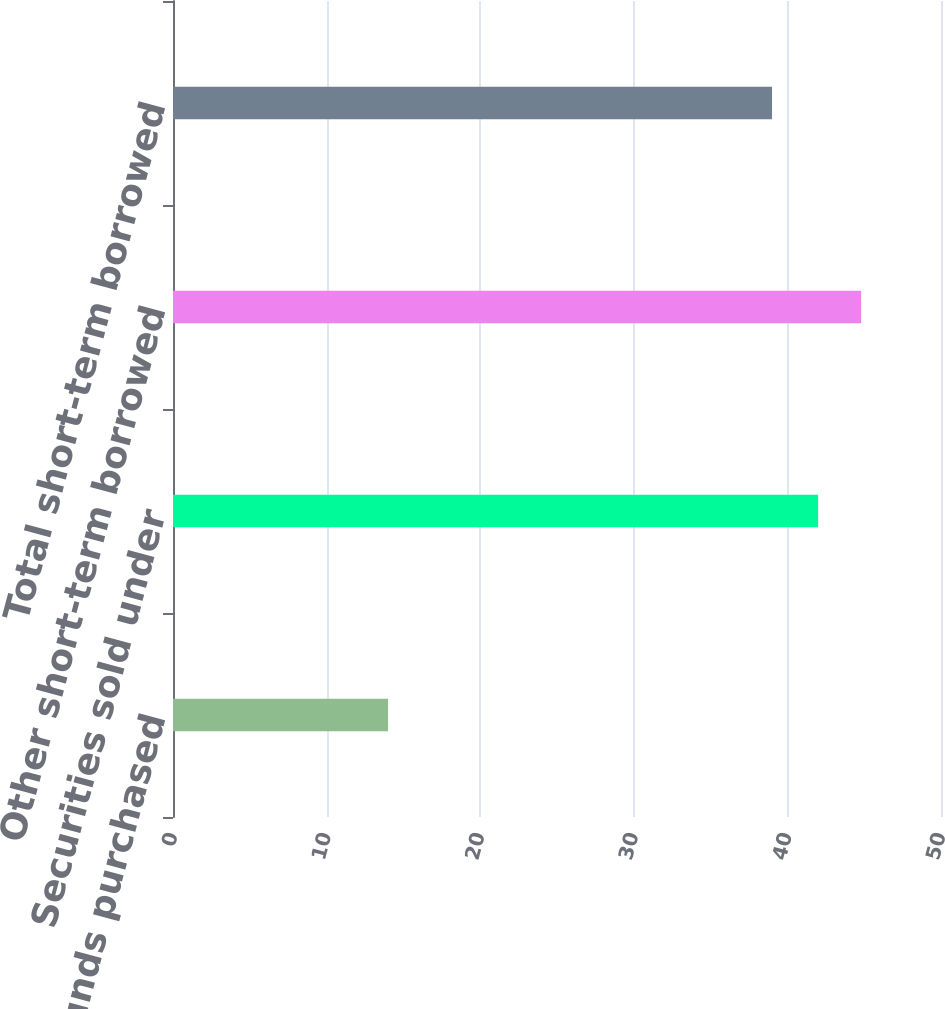Convert chart to OTSL. <chart><loc_0><loc_0><loc_500><loc_500><bar_chart><fcel>Federal funds purchased<fcel>Securities sold under<fcel>Other short-term borrowed<fcel>Total short-term borrowed<nl><fcel>14<fcel>42<fcel>44.8<fcel>39<nl></chart> 